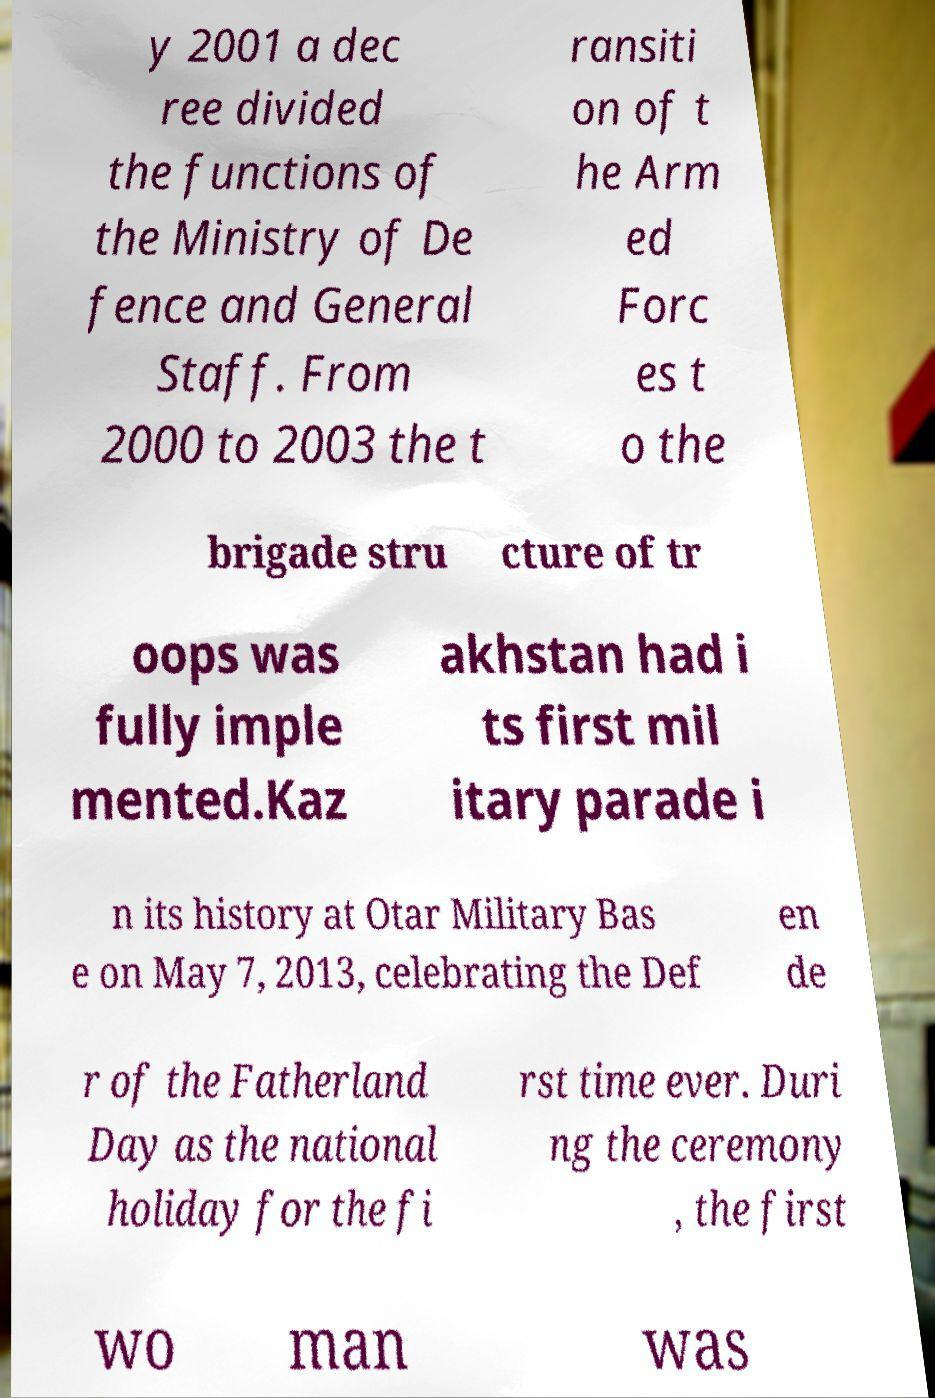Could you assist in decoding the text presented in this image and type it out clearly? y 2001 a dec ree divided the functions of the Ministry of De fence and General Staff. From 2000 to 2003 the t ransiti on of t he Arm ed Forc es t o the brigade stru cture of tr oops was fully imple mented.Kaz akhstan had i ts first mil itary parade i n its history at Otar Military Bas e on May 7, 2013, celebrating the Def en de r of the Fatherland Day as the national holiday for the fi rst time ever. Duri ng the ceremony , the first wo man was 